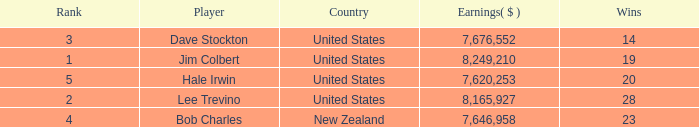How much have players earned with 14 wins ranked below 3? 0.0. 